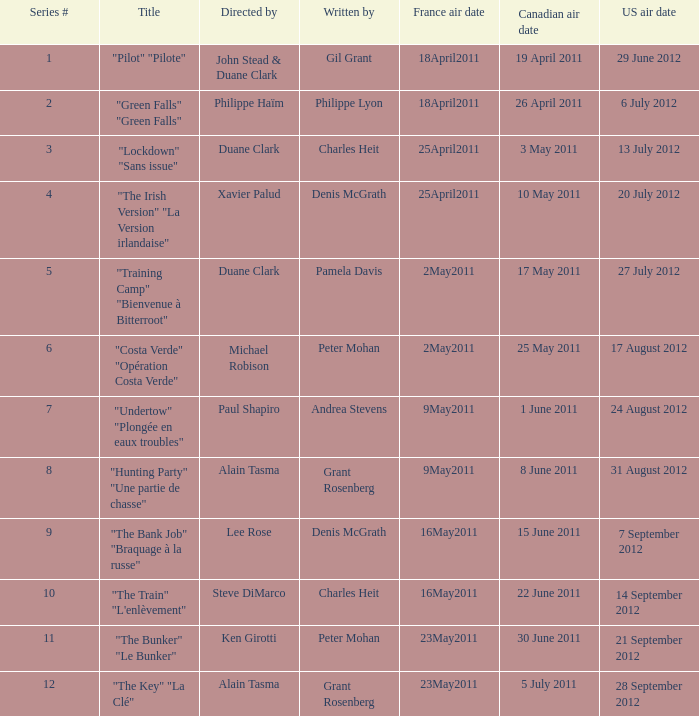What is the US air date when the director is ken girotti? 21 September 2012. 